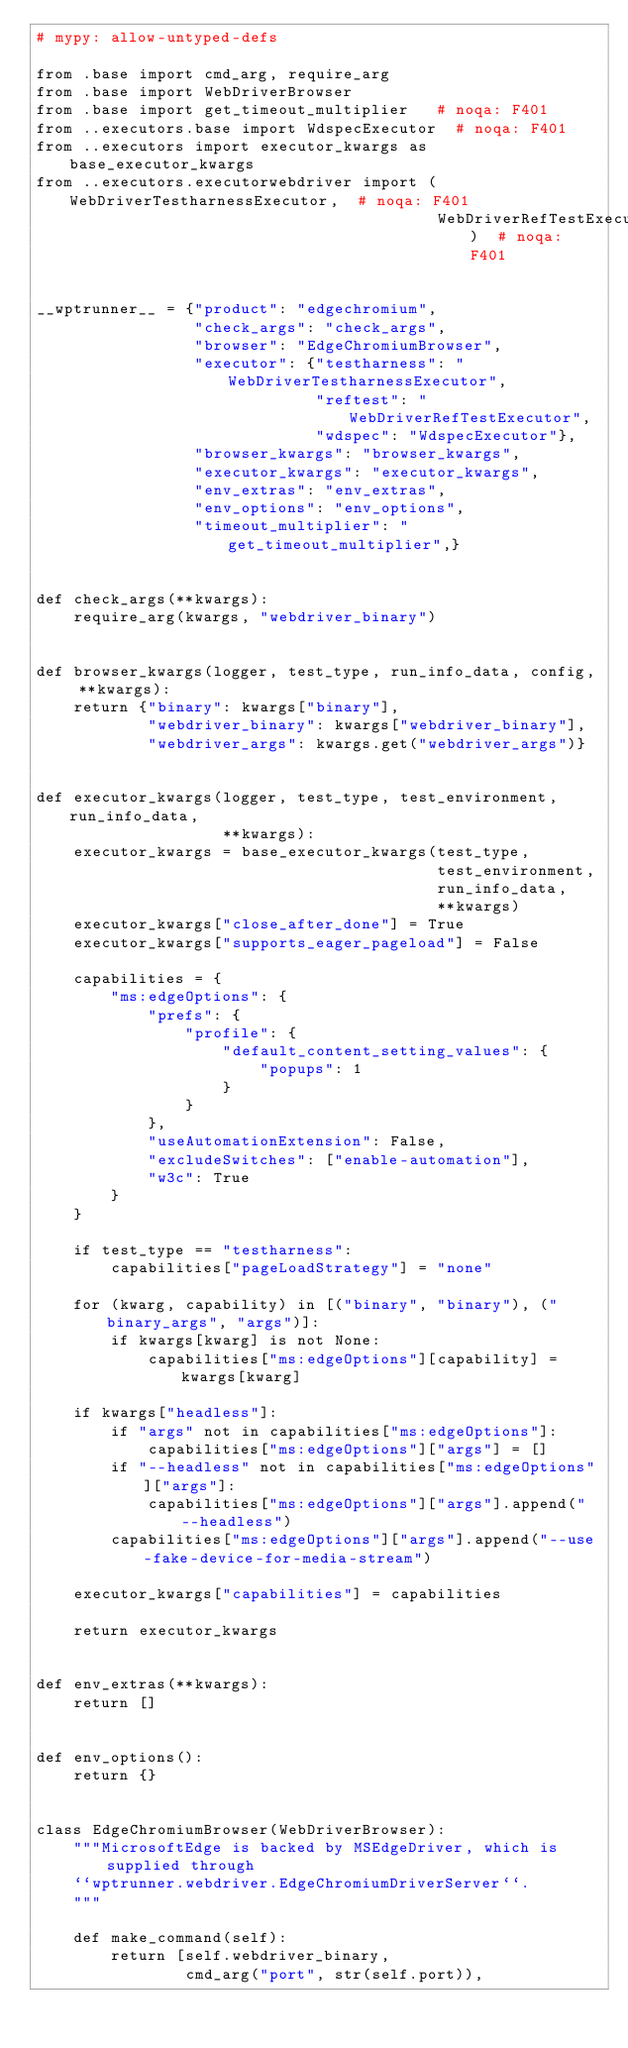<code> <loc_0><loc_0><loc_500><loc_500><_Python_># mypy: allow-untyped-defs

from .base import cmd_arg, require_arg
from .base import WebDriverBrowser
from .base import get_timeout_multiplier   # noqa: F401
from ..executors.base import WdspecExecutor  # noqa: F401
from ..executors import executor_kwargs as base_executor_kwargs
from ..executors.executorwebdriver import (WebDriverTestharnessExecutor,  # noqa: F401
                                           WebDriverRefTestExecutor)  # noqa: F401


__wptrunner__ = {"product": "edgechromium",
                 "check_args": "check_args",
                 "browser": "EdgeChromiumBrowser",
                 "executor": {"testharness": "WebDriverTestharnessExecutor",
                              "reftest": "WebDriverRefTestExecutor",
                              "wdspec": "WdspecExecutor"},
                 "browser_kwargs": "browser_kwargs",
                 "executor_kwargs": "executor_kwargs",
                 "env_extras": "env_extras",
                 "env_options": "env_options",
                 "timeout_multiplier": "get_timeout_multiplier",}


def check_args(**kwargs):
    require_arg(kwargs, "webdriver_binary")


def browser_kwargs(logger, test_type, run_info_data, config, **kwargs):
    return {"binary": kwargs["binary"],
            "webdriver_binary": kwargs["webdriver_binary"],
            "webdriver_args": kwargs.get("webdriver_args")}


def executor_kwargs(logger, test_type, test_environment, run_info_data,
                    **kwargs):
    executor_kwargs = base_executor_kwargs(test_type,
                                           test_environment,
                                           run_info_data,
                                           **kwargs)
    executor_kwargs["close_after_done"] = True
    executor_kwargs["supports_eager_pageload"] = False

    capabilities = {
        "ms:edgeOptions": {
            "prefs": {
                "profile": {
                    "default_content_setting_values": {
                        "popups": 1
                    }
                }
            },
            "useAutomationExtension": False,
            "excludeSwitches": ["enable-automation"],
            "w3c": True
        }
    }

    if test_type == "testharness":
        capabilities["pageLoadStrategy"] = "none"

    for (kwarg, capability) in [("binary", "binary"), ("binary_args", "args")]:
        if kwargs[kwarg] is not None:
            capabilities["ms:edgeOptions"][capability] = kwargs[kwarg]

    if kwargs["headless"]:
        if "args" not in capabilities["ms:edgeOptions"]:
            capabilities["ms:edgeOptions"]["args"] = []
        if "--headless" not in capabilities["ms:edgeOptions"]["args"]:
            capabilities["ms:edgeOptions"]["args"].append("--headless")
        capabilities["ms:edgeOptions"]["args"].append("--use-fake-device-for-media-stream")

    executor_kwargs["capabilities"] = capabilities

    return executor_kwargs


def env_extras(**kwargs):
    return []


def env_options():
    return {}


class EdgeChromiumBrowser(WebDriverBrowser):
    """MicrosoftEdge is backed by MSEdgeDriver, which is supplied through
    ``wptrunner.webdriver.EdgeChromiumDriverServer``.
    """

    def make_command(self):
        return [self.webdriver_binary,
                cmd_arg("port", str(self.port)),</code> 